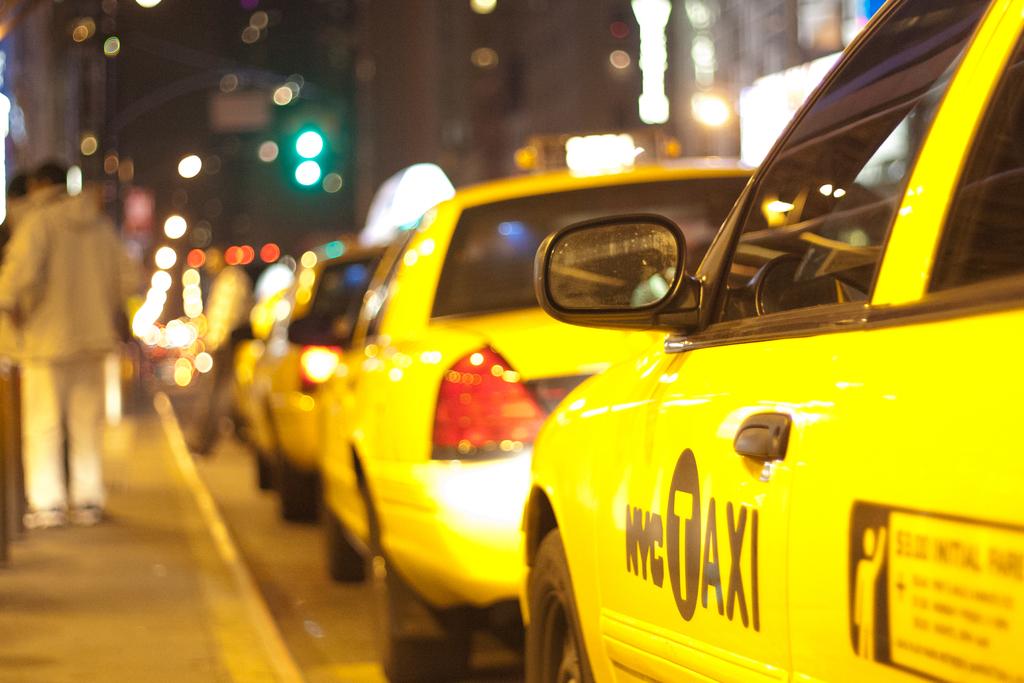What city is this taxi in?
Your answer should be compact. Nyc. This is rent cars?
Your answer should be compact. No. 